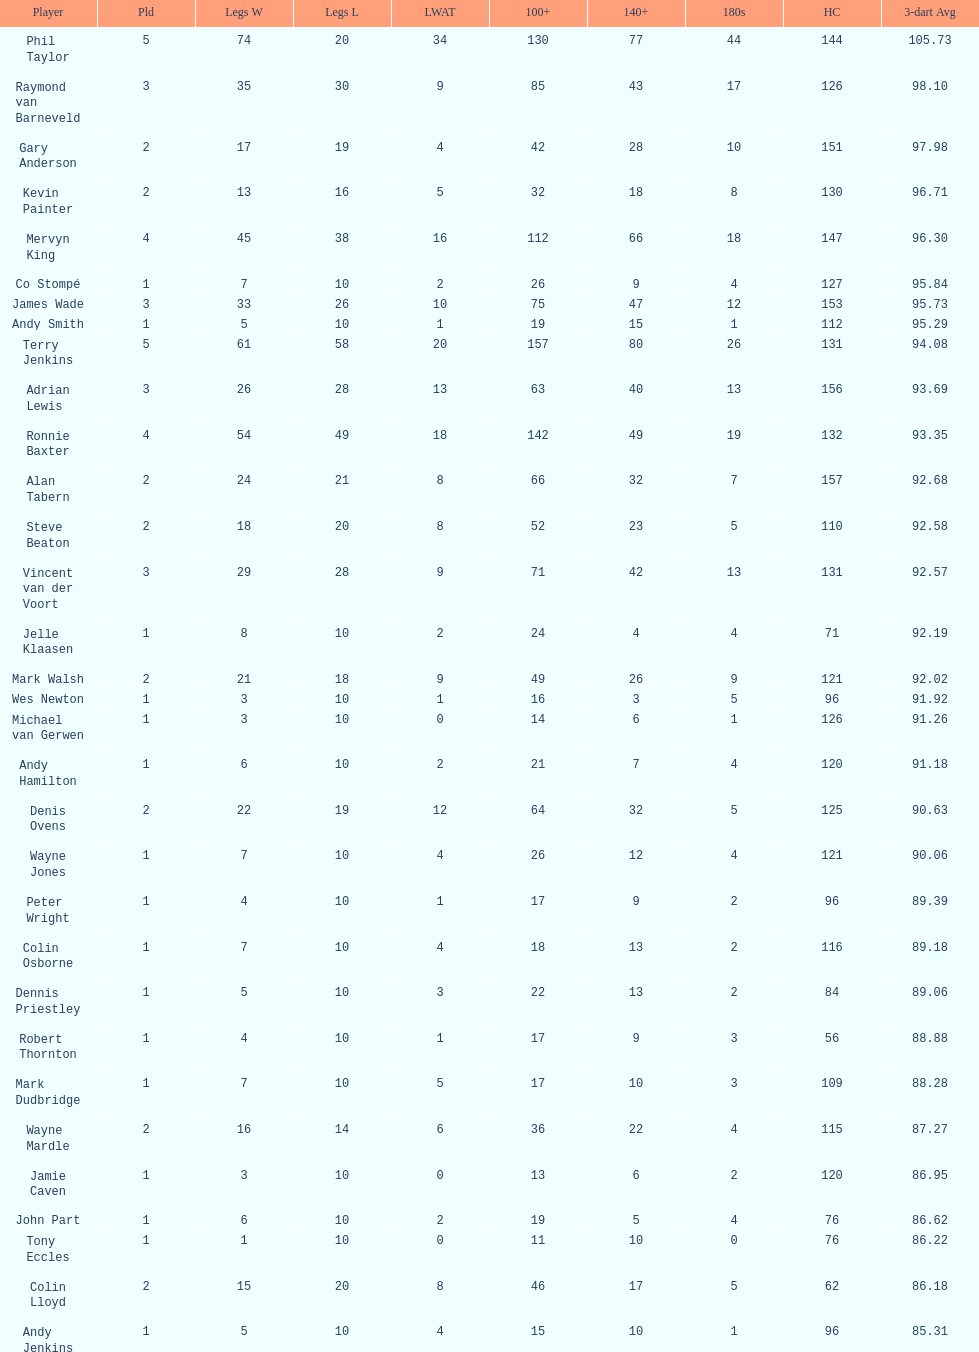Which player experienced the least defeat? Co Stompé, Andy Smith, Jelle Klaasen, Wes Newton, Michael van Gerwen, Andy Hamilton, Wayne Jones, Peter Wright, Colin Osborne, Dennis Priestley, Robert Thornton, Mark Dudbridge, Jamie Caven, John Part, Tony Eccles, Andy Jenkins. 